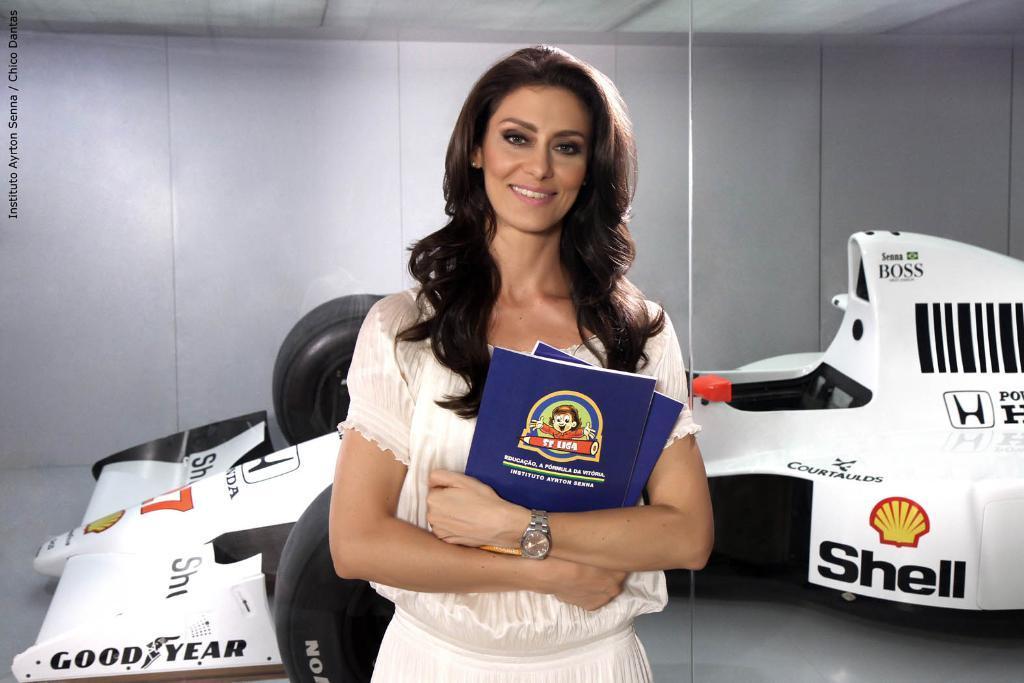Could you give a brief overview of what you see in this image? In this image we can see a woman smiling and holding the books, behind her, we can see a white color vehicle and in the background, we can see the wall. 